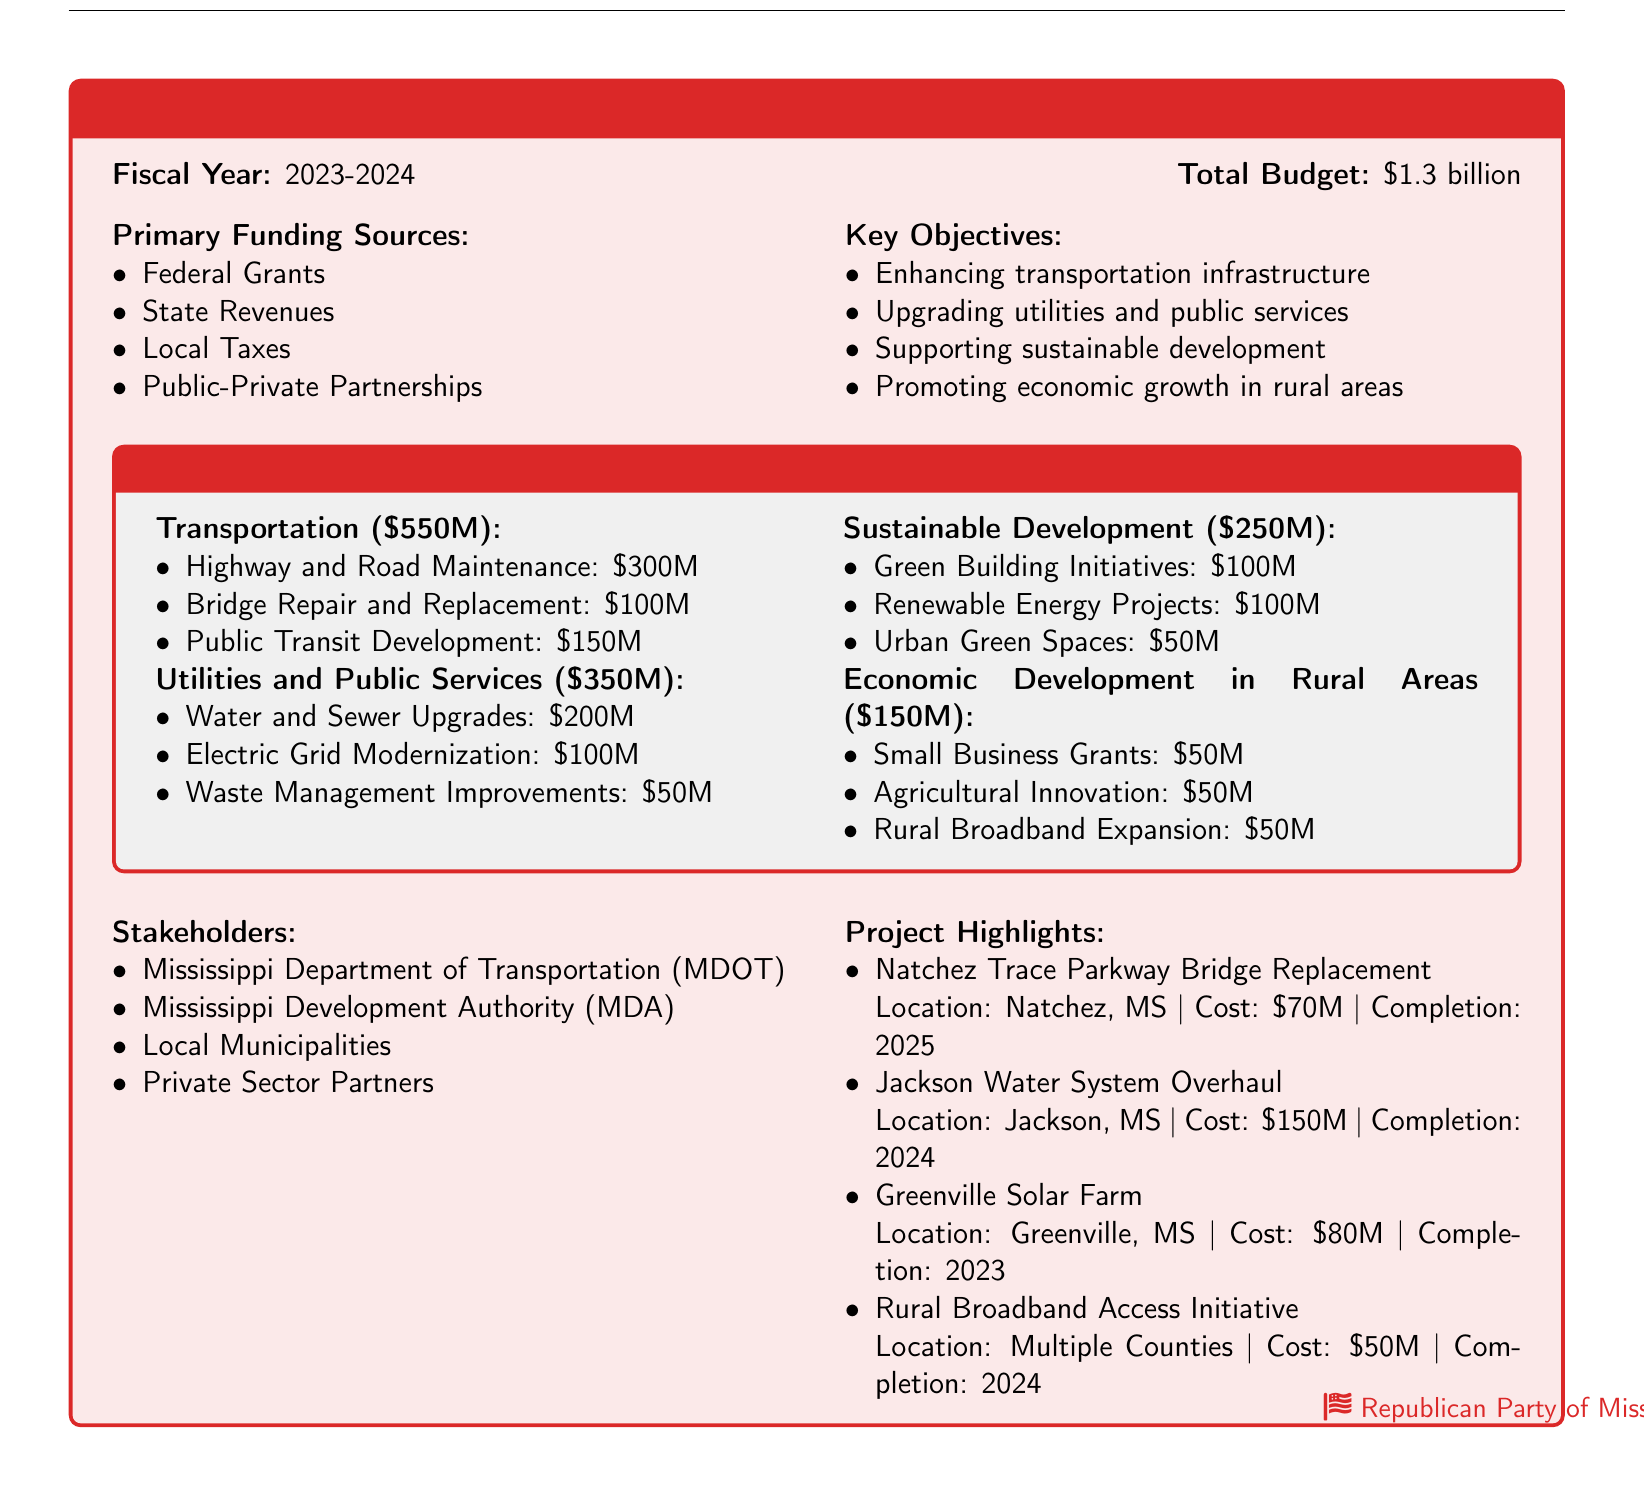What is the total budget for the fiscal year 2023-2024? The fiscal year total budget is explicitly stated in the document.
Answer: $1.3 billion What is the amount allocated for transportation? The specific allocation for transportation is provided in the document under the allocation breakdown.
Answer: $550 million How many key objectives are mentioned in the document? The key objectives are listed in a bulleted format, and their total count gives the answer.
Answer: 4 What is the budget for water and sewer upgrades? The budget for water and sewer upgrades is detailed in the utilities and public services section.
Answer: $200 million Which agency is responsible for overseeing local infrastructure projects? The document lists stakeholders involved, including the primary agency in charge.
Answer: Mississippi Department of Transportation (MDOT) How much funding is allocated for rural broadband expansion? The budget for rural broadband expansion is specified in the economic development in rural areas section.
Answer: $50 million What project is highlighted with a cost of $70 million? The document lists project highlights along with their respective costs and locations.
Answer: Natchez Trace Parkway Bridge Replacement What is the completion year for the Jackson Water System Overhaul? The completion date for the project is included in the project highlights.
Answer: 2024 What is the total budget for sustainable development initiatives? The allocation amount for sustainable development is provided in the breakdown section of the document.
Answer: $250 million 